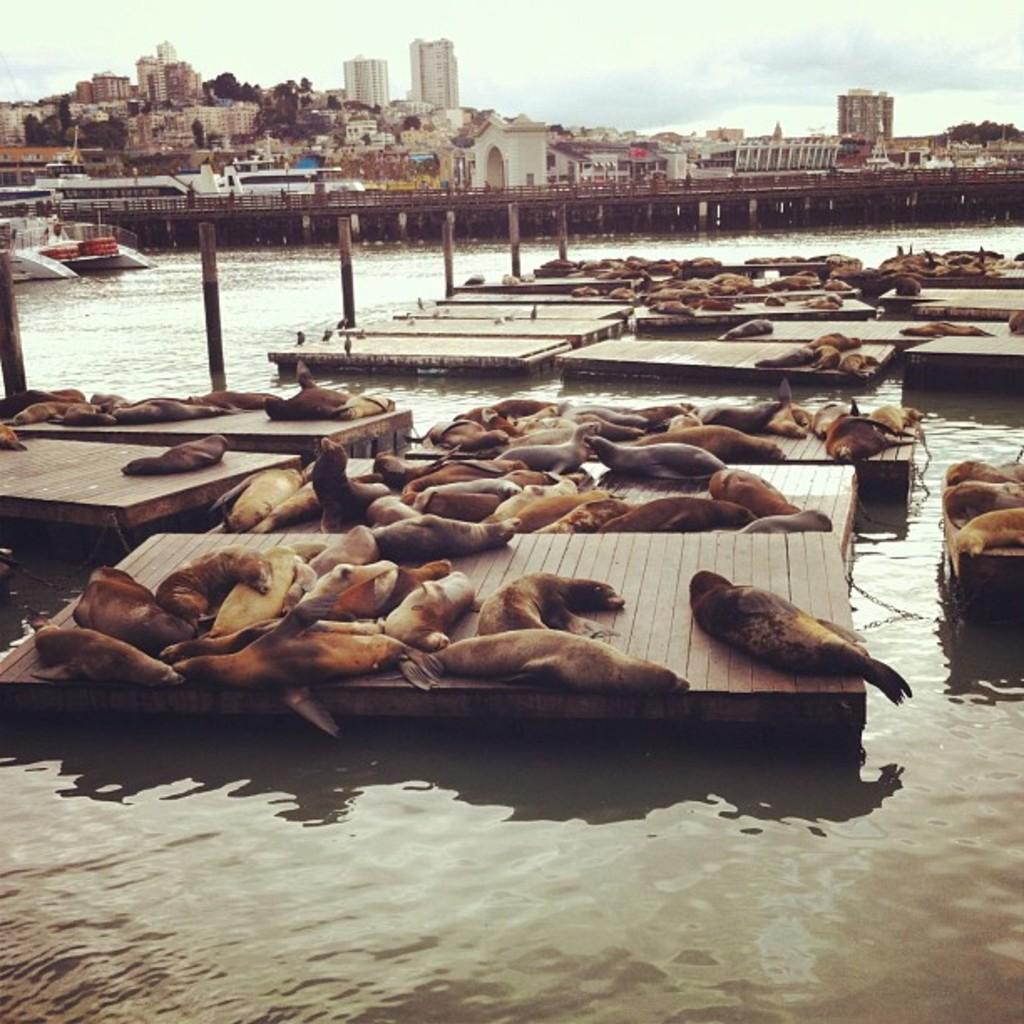In one or two sentences, can you explain what this image depicts? In this image there is the sky, there are buildings, there is an object truncated towards the left of the image, there is water truncated towards the bottom of the image, there are animals on the ground, there are animals truncated towards the right of the image. 